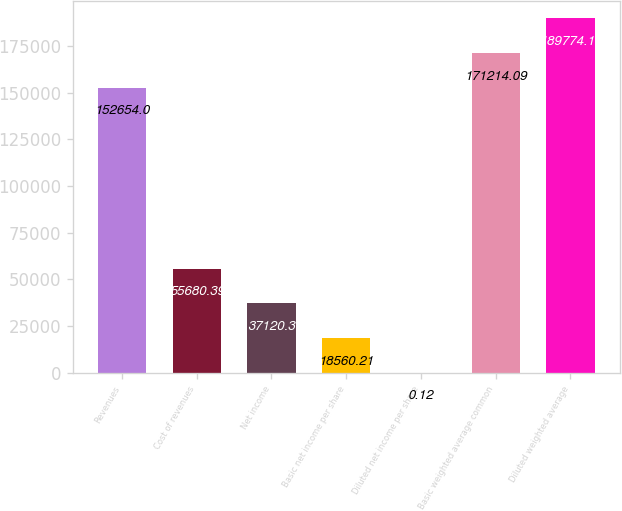<chart> <loc_0><loc_0><loc_500><loc_500><bar_chart><fcel>Revenues<fcel>Cost of revenues<fcel>Net income<fcel>Basic net income per share<fcel>Diluted net income per share<fcel>Basic weighted average common<fcel>Diluted weighted average<nl><fcel>152654<fcel>55680.4<fcel>37120.3<fcel>18560.2<fcel>0.12<fcel>171214<fcel>189774<nl></chart> 